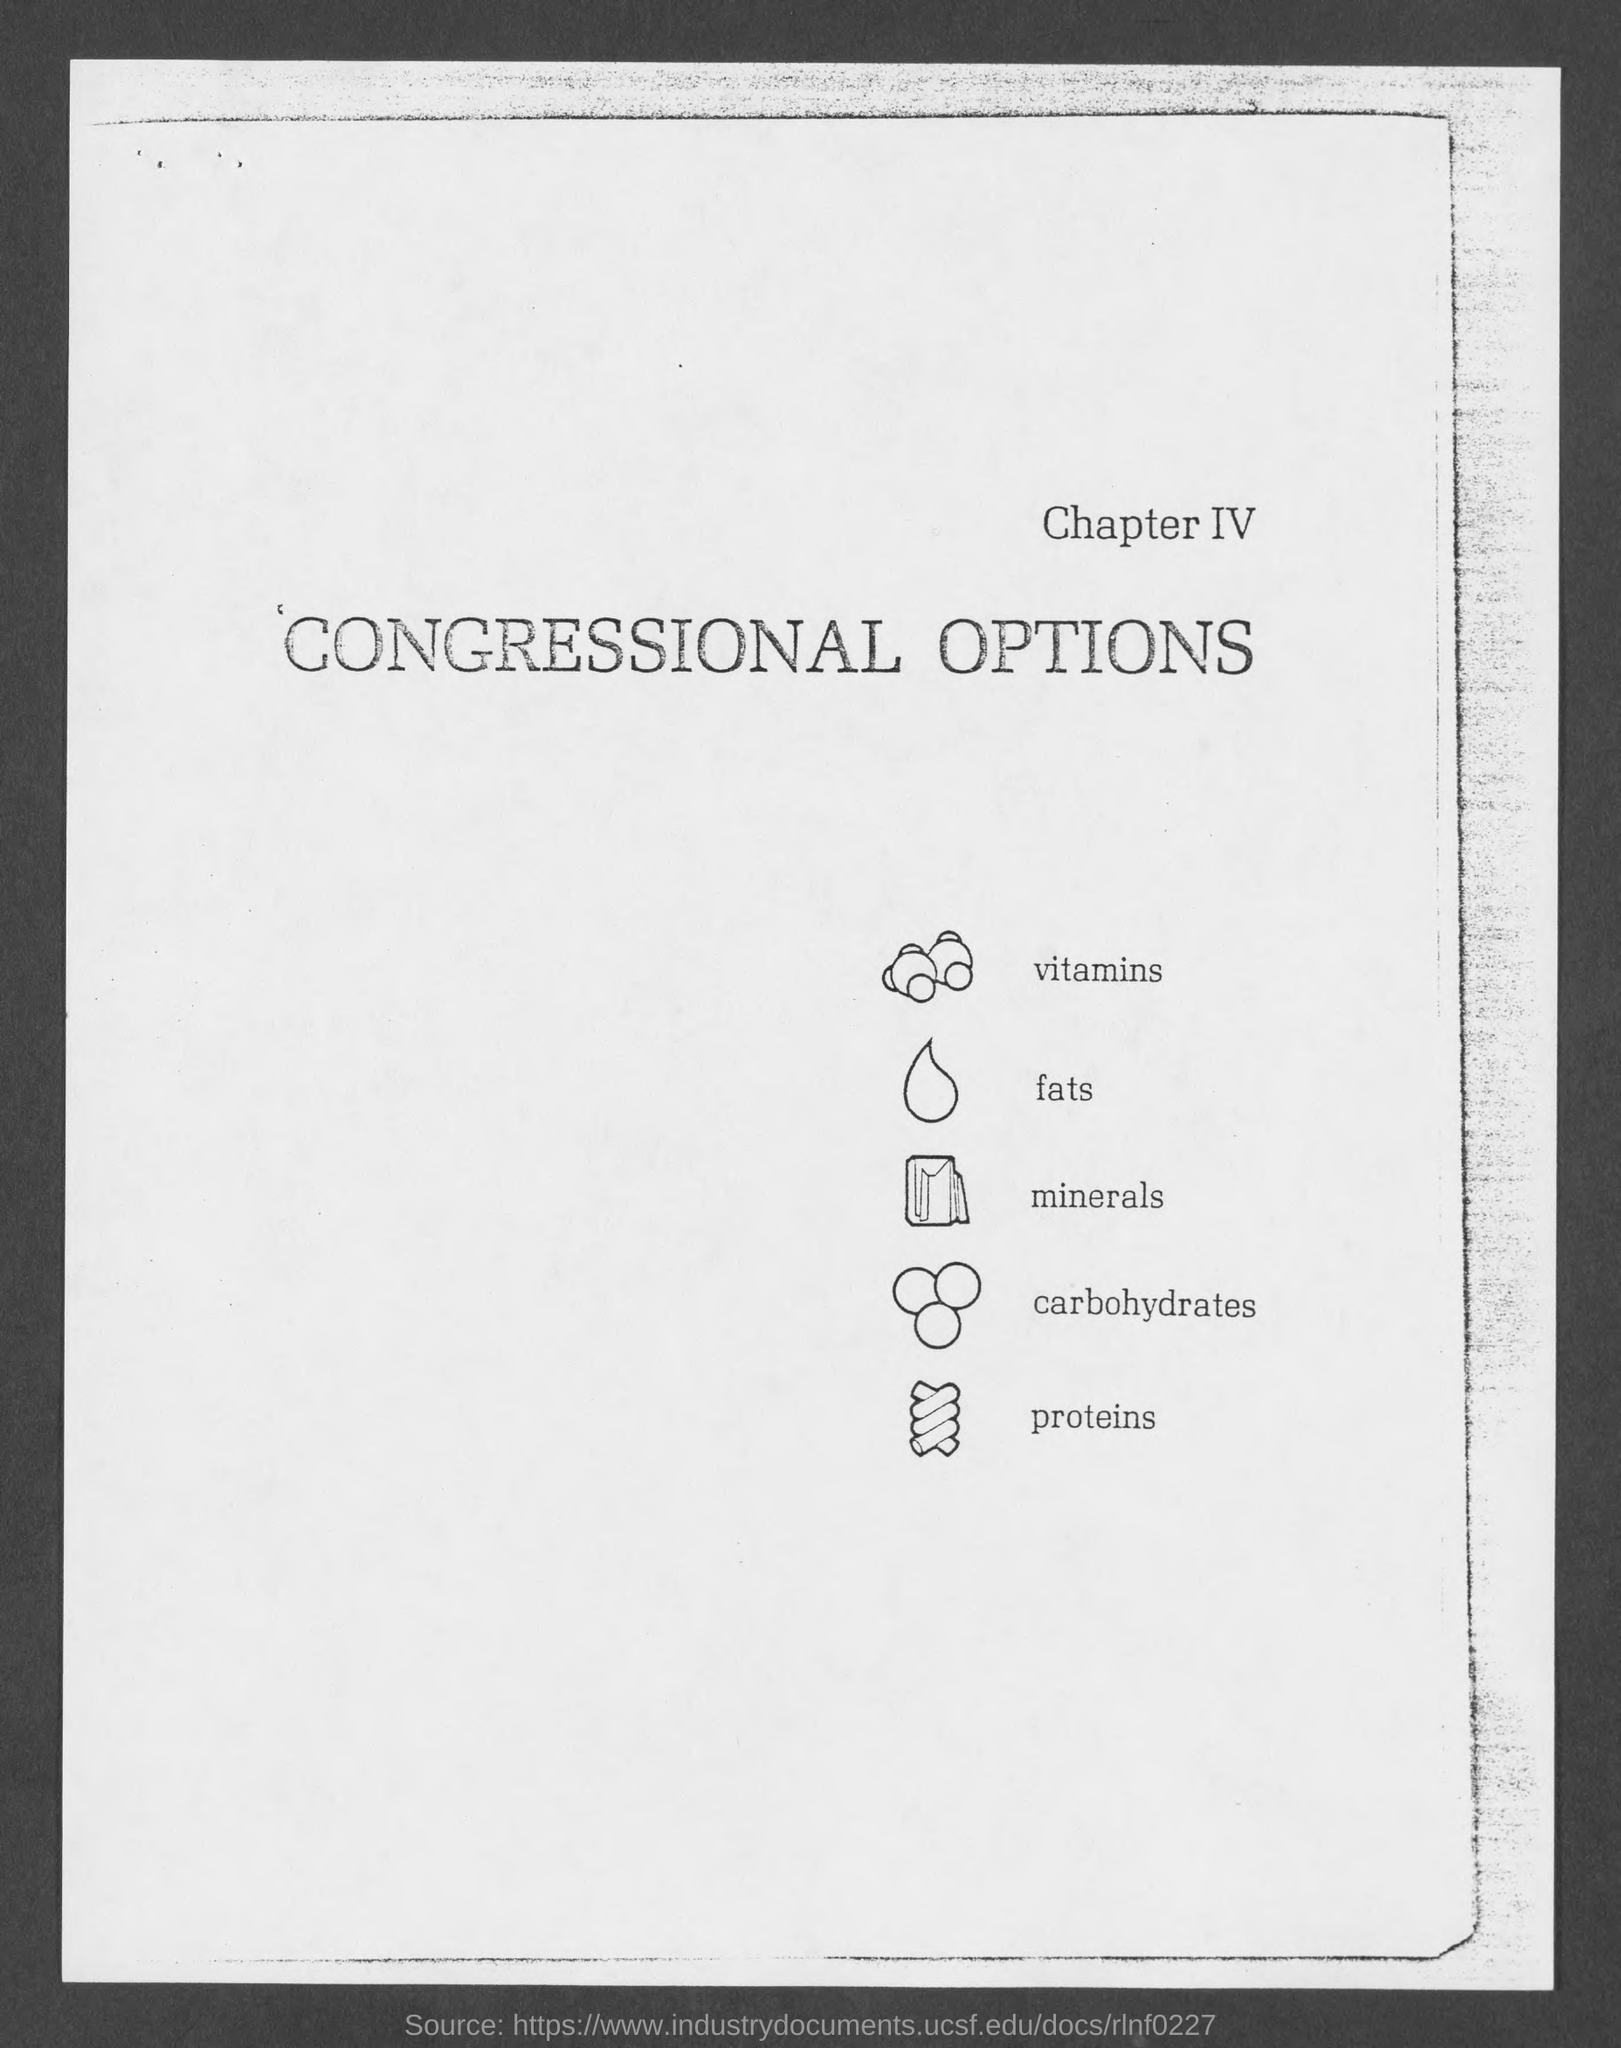Draw attention to some important aspects in this diagram. The fourth image depicts the nutrient carbohydrates. The second image depicts the nutrient fat. The first title in the document is Chapter IV. The third image depicts minerals, which is the correct answer. The first image depicts vitamins, which are a type of nutrient. 